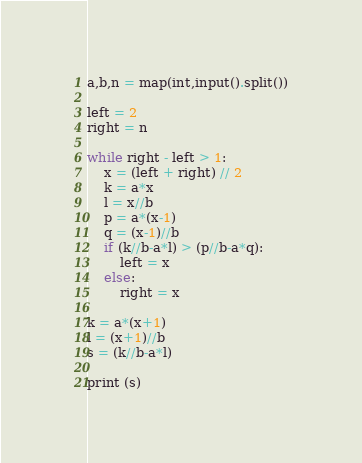Convert code to text. <code><loc_0><loc_0><loc_500><loc_500><_Python_>a,b,n = map(int,input().split())

left = 2
right = n

while right - left > 1:
    x = (left + right) // 2
    k = a*x
    l = x//b
    p = a*(x-1)
    q = (x-1)//b
    if (k//b-a*l) > (p//b-a*q):
        left = x
    else:
        right = x

k = a*(x+1)
l = (x+1)//b
s = (k//b-a*l)

print (s)
</code> 